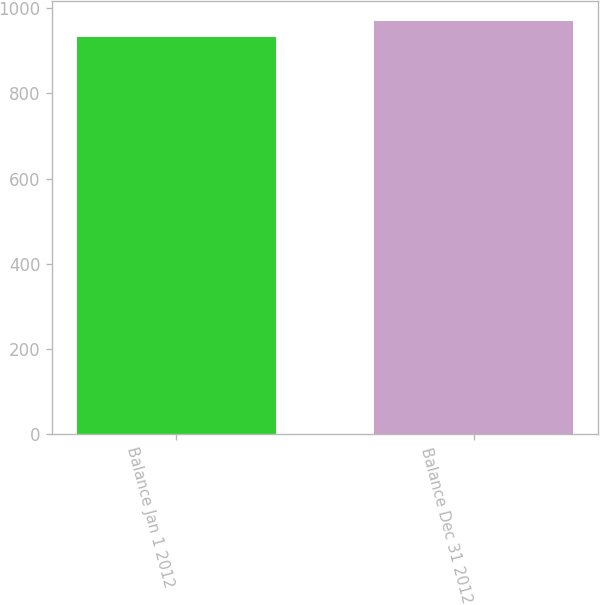<chart> <loc_0><loc_0><loc_500><loc_500><bar_chart><fcel>Balance Jan 1 2012<fcel>Balance Dec 31 2012<nl><fcel>933<fcel>970<nl></chart> 